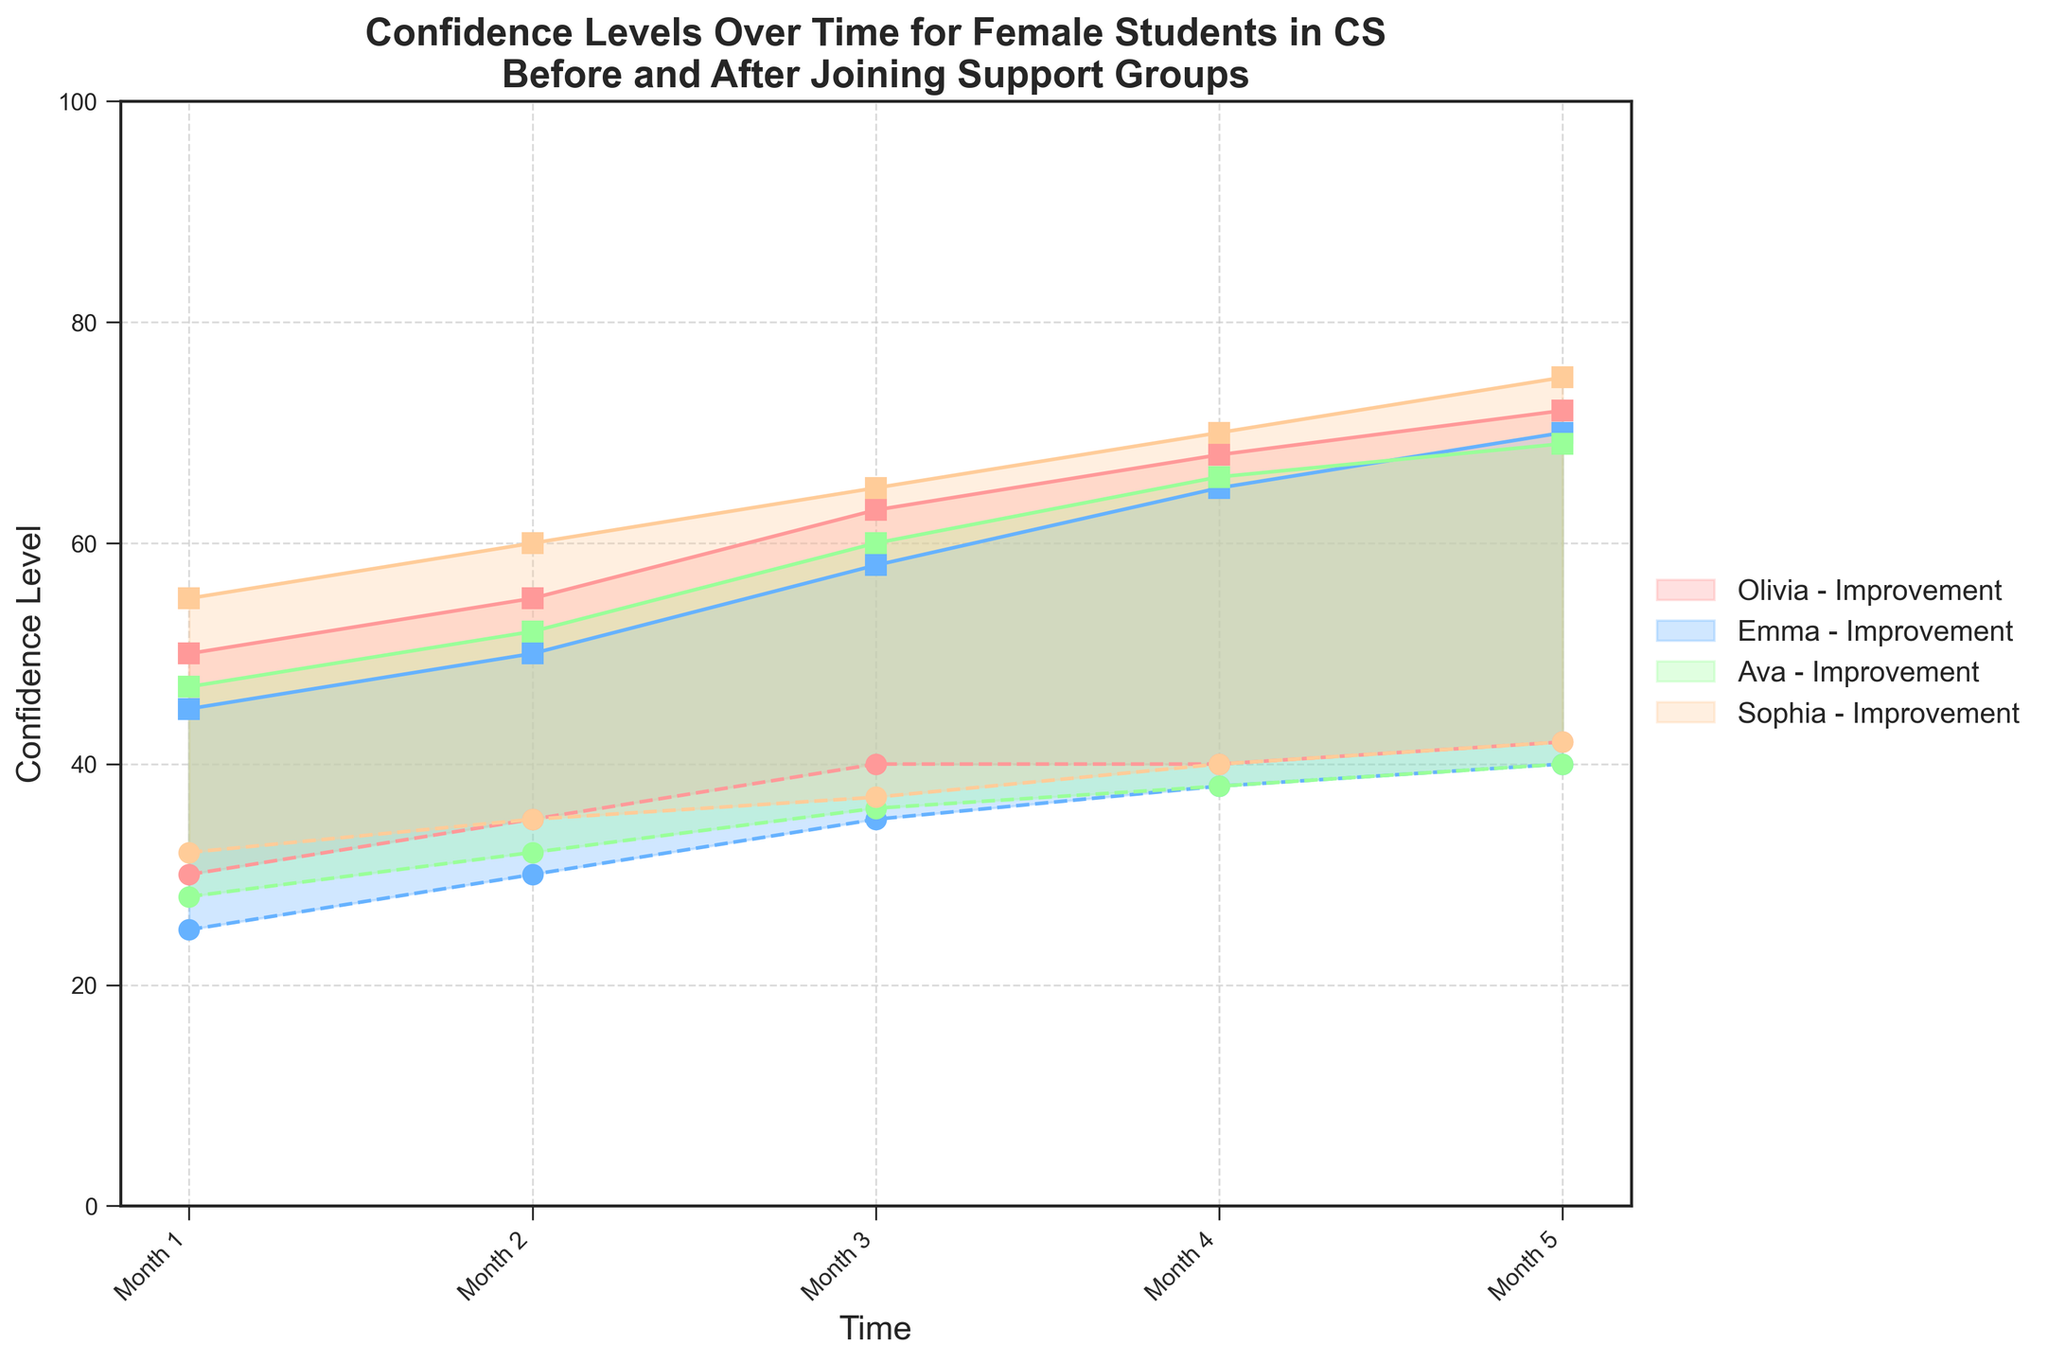What is the title of the figure? The title is located at the top of the figure. It reads: 'Confidence Levels Over Time for Female Students in CS Before and After Joining Support Groups'.
Answer: Confidence Levels Over Time for Female Students in CS Before and After Joining Support Groups What is the range of the y-axis? The y-axis measures Confidence Level and ranges from 0 to 100, as seen by the labels extending from the bottom to the top of the y-axis.
Answer: 0 to 100 Which student had the highest final confidence level after joining a support group? By looking at the final data points for all students on the right side of the plot, we see that Sophia's confidence level after joining a support group is the highest, at 75.
Answer: Sophia How does Olivia's confidence level before joining a support group change from Month 1 to Month 3? Olivia's confidence level before joining a support group increases from 30 in Month 1 to 40 in Month 3, as seen at the intersection of her data line and the corresponding months on the x-axis.
Answer: Increased from 30 to 40 What is the improvement in Emma's confidence level from before to after joining the support group in Month 2? In Month 2, Emma's confidence level increased from 30 before joining the support group to 50 after joining. The difference is 50 - 30 = 20.
Answer: 20 Which student shows the most significant improvement in confidence level in Month 5? Comparing the difference between confidence levels before and after joining the support group in Month 5, Sophia shows the most significant improvement from 42 to 75, which is an increase of 33.
Answer: Sophia What trend can be observed in Ava's confidence level before joining the support group over time? Observing Ava’s confidence level line before joining the support group, we see a consistent upward trend from 28 in Month 1 to 40 in Month 5.
Answer: Upward trend How does the confidence level gap change for Olivia from Month 1 to Month 4 after joining the support group? For Olivia, the gap between confidence levels before and after joining the support group increases. In Month 1, the gap is 50 - 30 = 20. In Month 4, it is 68 - 40 = 28. The gap has increased by 8.
Answer: Increased by 8 By Month 5, which student has the smallest difference in confidence levels before and after joining the support group? By Month 5, calculating the differences, we see Ava has the smallest difference of 29 (69 - 40) compared to the other students.
Answer: Ava What is the average confidence level after joining a support group for all students in Month 3? Summing the confidence levels after joining a support group for Month 3: 63 (Olivia) + 58 (Emma) + 60 (Ava) + 65 (Sophia) = 246. Dividing by 4 students, the average is 246 / 4 = 61.5.
Answer: 61.5 